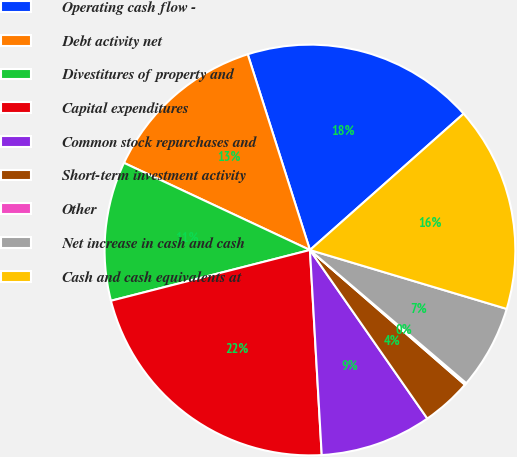Convert chart to OTSL. <chart><loc_0><loc_0><loc_500><loc_500><pie_chart><fcel>Operating cash flow -<fcel>Debt activity net<fcel>Divestitures of property and<fcel>Capital expenditures<fcel>Common stock repurchases and<fcel>Short-term investment activity<fcel>Other<fcel>Net increase in cash and cash<fcel>Cash and cash equivalents at<nl><fcel>18.35%<fcel>13.13%<fcel>10.95%<fcel>21.94%<fcel>8.77%<fcel>3.93%<fcel>0.16%<fcel>6.6%<fcel>16.18%<nl></chart> 